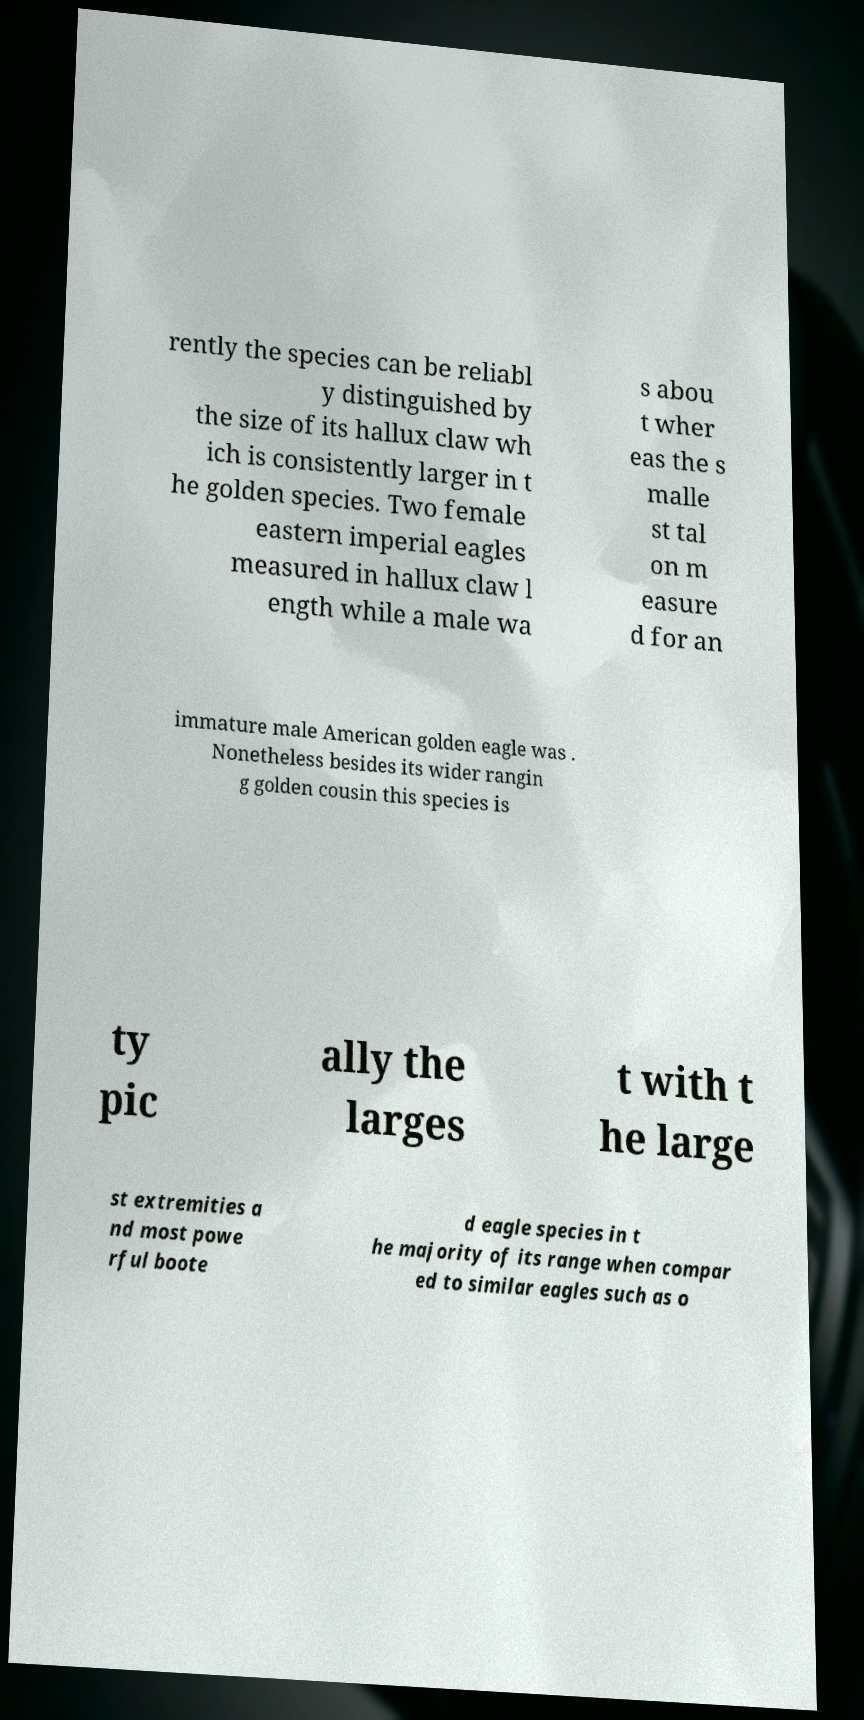Could you assist in decoding the text presented in this image and type it out clearly? rently the species can be reliabl y distinguished by the size of its hallux claw wh ich is consistently larger in t he golden species. Two female eastern imperial eagles measured in hallux claw l ength while a male wa s abou t wher eas the s malle st tal on m easure d for an immature male American golden eagle was . Nonetheless besides its wider rangin g golden cousin this species is ty pic ally the larges t with t he large st extremities a nd most powe rful boote d eagle species in t he majority of its range when compar ed to similar eagles such as o 